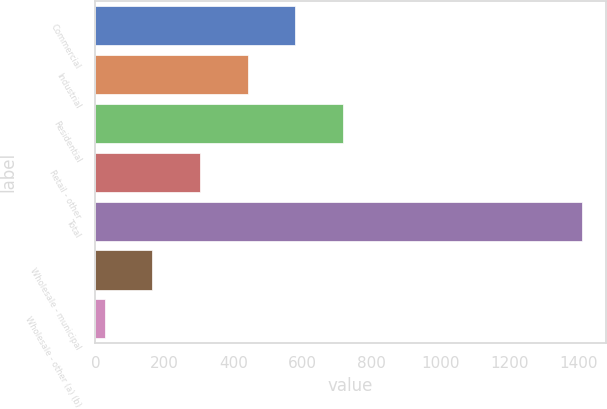<chart> <loc_0><loc_0><loc_500><loc_500><bar_chart><fcel>Commercial<fcel>Industrial<fcel>Residential<fcel>Retail - other<fcel>Total<fcel>Wholesale - municipal<fcel>Wholesale - other (a) (b)<nl><fcel>580.2<fcel>441.9<fcel>718.5<fcel>303.6<fcel>1410<fcel>165.3<fcel>27<nl></chart> 